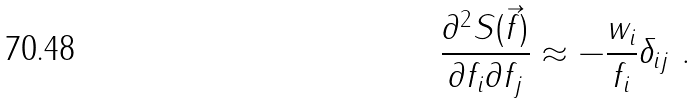Convert formula to latex. <formula><loc_0><loc_0><loc_500><loc_500>\frac { \partial ^ { 2 } S ( \vec { f } ) } { \partial f _ { i } \partial f _ { j } } \approx - \frac { w _ { i } } { f _ { i } } \delta _ { i j } \ .</formula> 